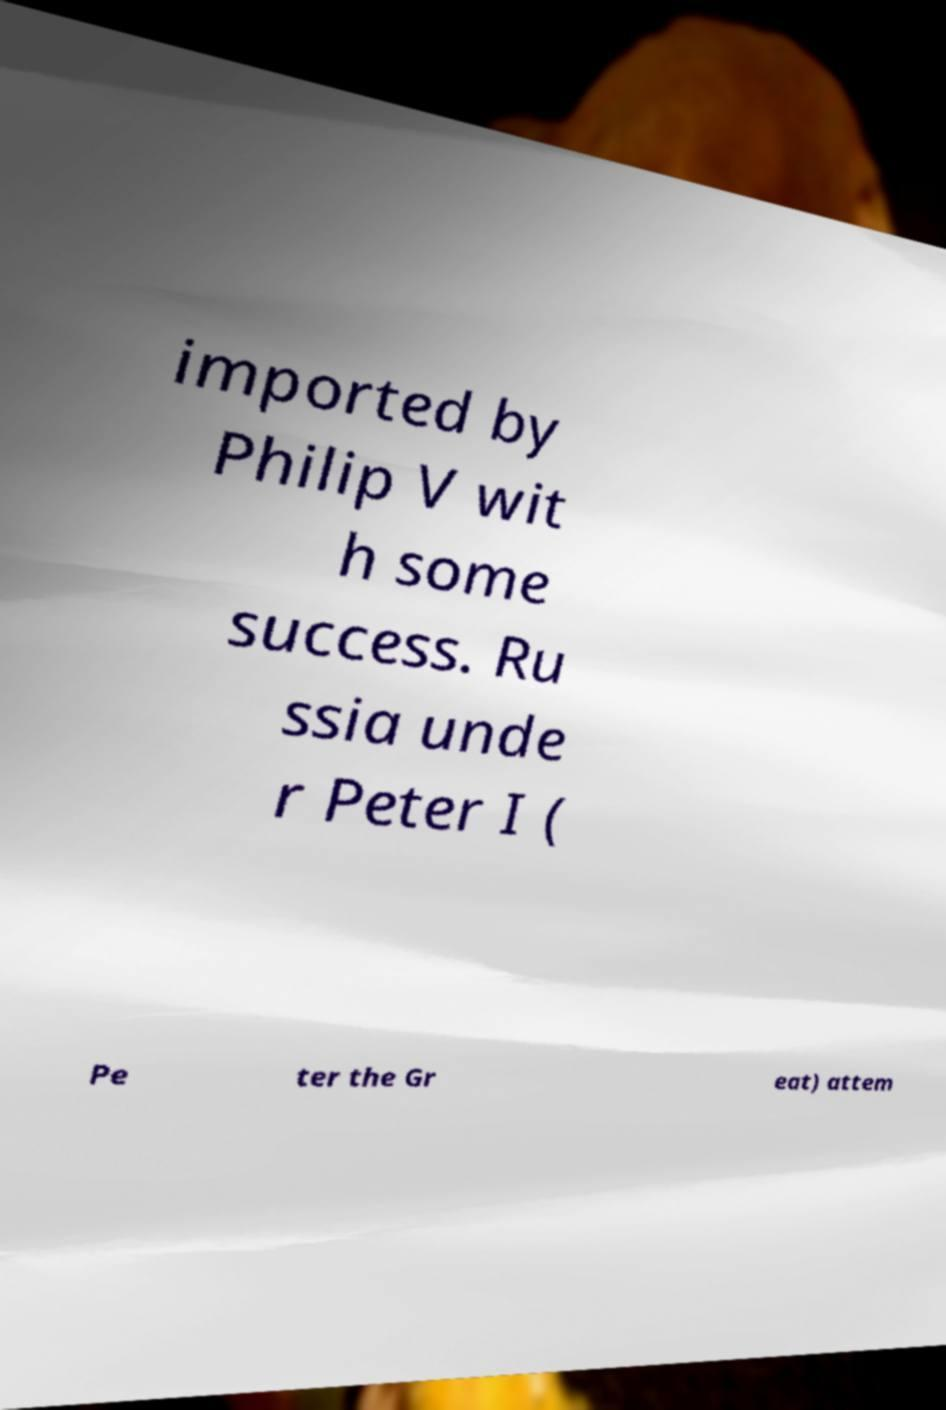Please read and relay the text visible in this image. What does it say? imported by Philip V wit h some success. Ru ssia unde r Peter I ( Pe ter the Gr eat) attem 